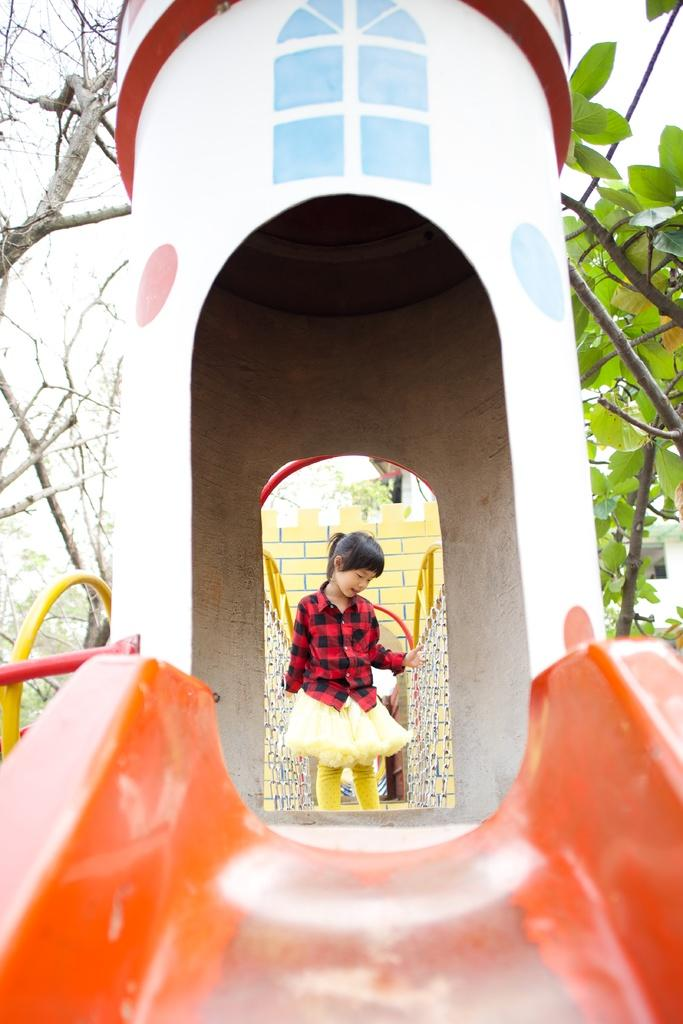Who is the main subject in the image? There is a girl in the image. What is located in the foreground of the image? There is a slide in the foreground of the image. What can be seen in the background of the image? There are trees in the background of the image. How does the girl grip the slide in the image? The girl is not gripping the slide in the image; she is likely standing near the slide. 